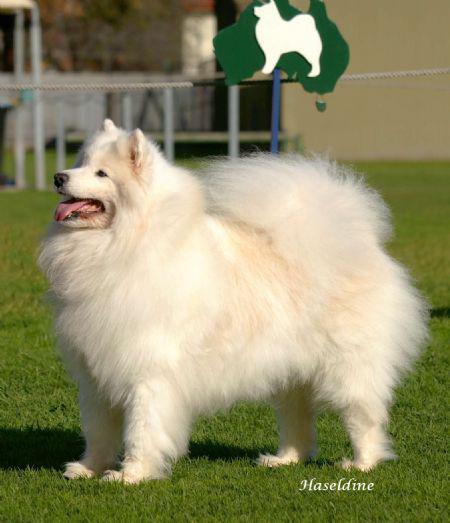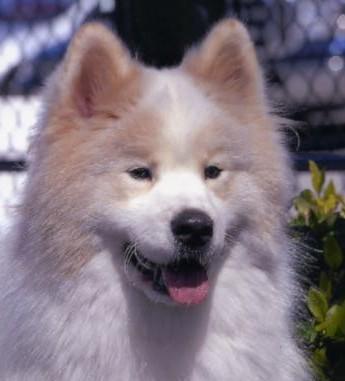The first image is the image on the left, the second image is the image on the right. For the images shown, is this caption "An image shows just one fluffy dog standing on grass." true? Answer yes or no. Yes. The first image is the image on the left, the second image is the image on the right. Analyze the images presented: Is the assertion "There is at least one dog facing the camera in the image on the left" valid? Answer yes or no. No. 